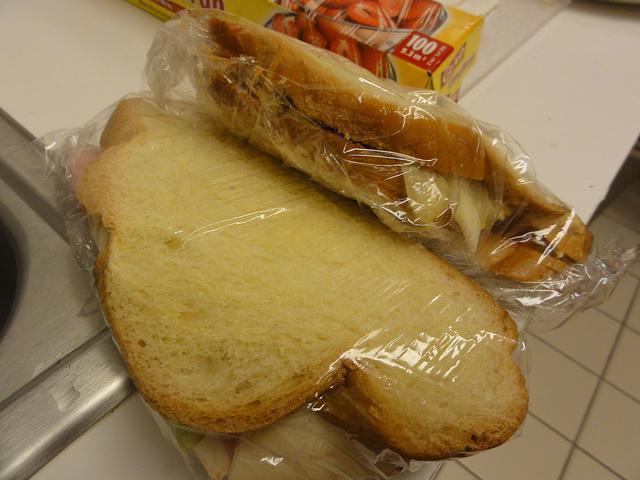What has made the sandwiches to look shiny?
Indicate the correct response by choosing from the four available options to answer the question.
Options: Saran wrap, glass, icing, butter. Saran wrap. 